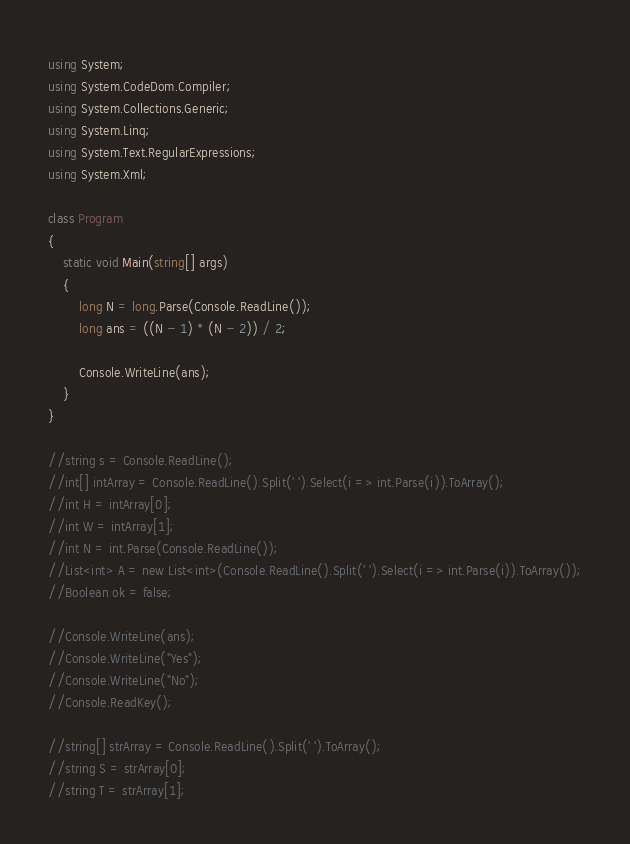<code> <loc_0><loc_0><loc_500><loc_500><_C#_>using System;
using System.CodeDom.Compiler;
using System.Collections.Generic;
using System.Linq;
using System.Text.RegularExpressions;
using System.Xml;

class Program
{
	static void Main(string[] args)
	{
		long N = long.Parse(Console.ReadLine());
		long ans = ((N - 1) * (N - 2)) / 2;

		Console.WriteLine(ans);
	}
}

//string s = Console.ReadLine();
//int[] intArray = Console.ReadLine().Split(' ').Select(i => int.Parse(i)).ToArray();
//int H = intArray[0];
//int W = intArray[1];
//int N = int.Parse(Console.ReadLine());
//List<int> A = new List<int>(Console.ReadLine().Split(' ').Select(i => int.Parse(i)).ToArray());
//Boolean ok = false;

//Console.WriteLine(ans);
//Console.WriteLine("Yes");
//Console.WriteLine("No");
//Console.ReadKey();

//string[] strArray = Console.ReadLine().Split(' ').ToArray();
//string S = strArray[0];
//string T = strArray[1];
</code> 